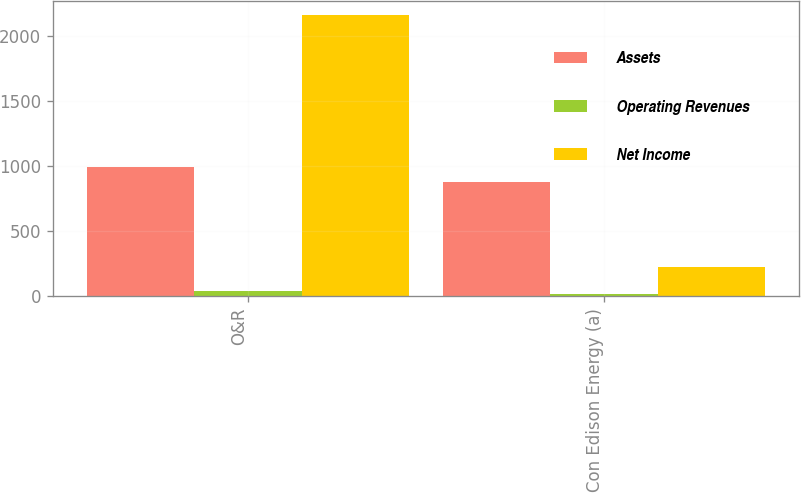Convert chart to OTSL. <chart><loc_0><loc_0><loc_500><loc_500><stacked_bar_chart><ecel><fcel>O&R<fcel>Con Edison Energy (a)<nl><fcel>Assets<fcel>991<fcel>878<nl><fcel>Operating Revenues<fcel>44<fcel>17<nl><fcel>Net Income<fcel>2157<fcel>223<nl></chart> 